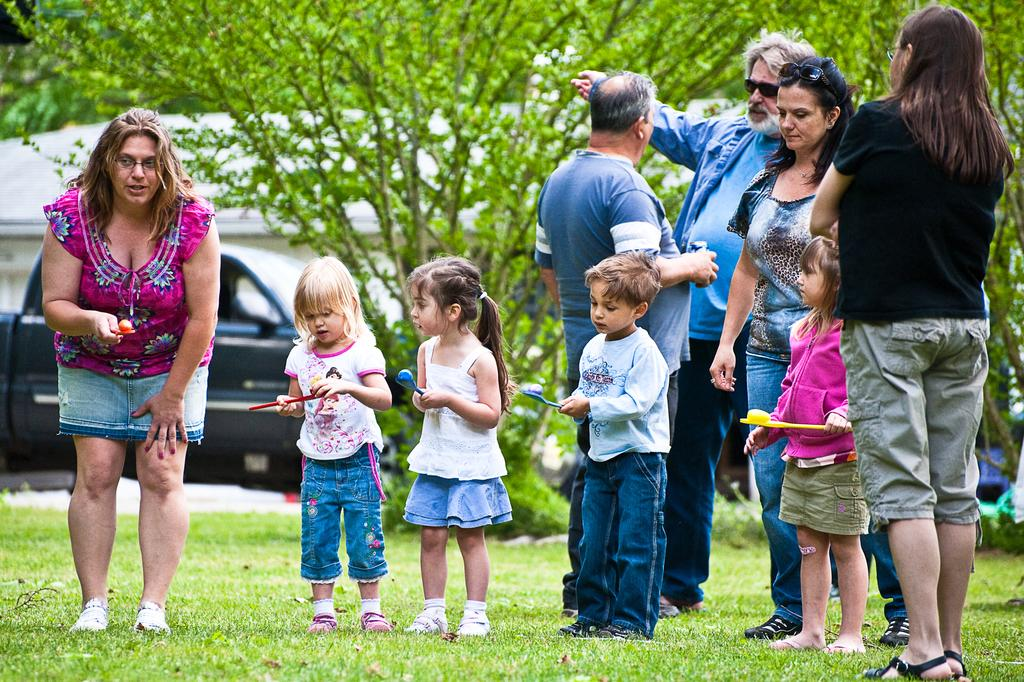What is happening in the image? There are people standing in the image. What are some of the people holding? Some of the people are holding objects. What type of natural environment is visible in the image? There are trees and grass in the image. What man-made structures can be seen in the image? There is a vehicle and a house in the image. What type of tub is visible in the image? There is no tub present in the image. What part of the world are the people on a voyage to in the image? There is no indication of a voyage or a specific destination in the image. 